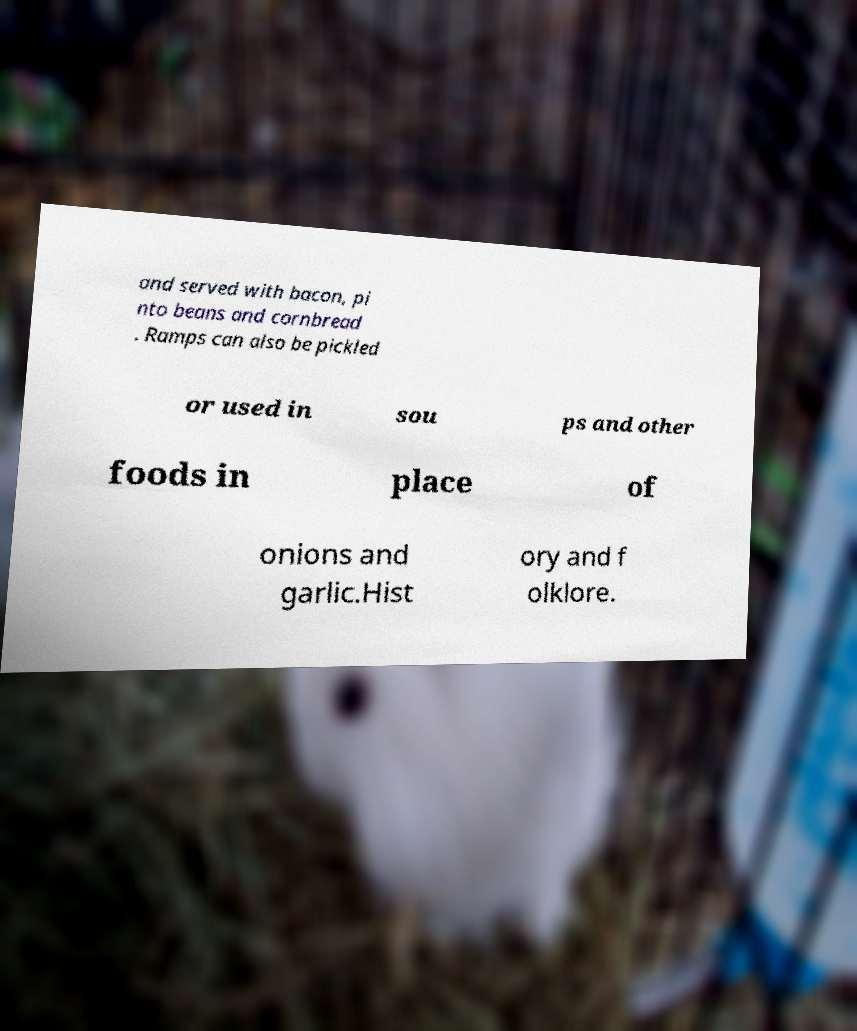Could you extract and type out the text from this image? and served with bacon, pi nto beans and cornbread . Ramps can also be pickled or used in sou ps and other foods in place of onions and garlic.Hist ory and f olklore. 